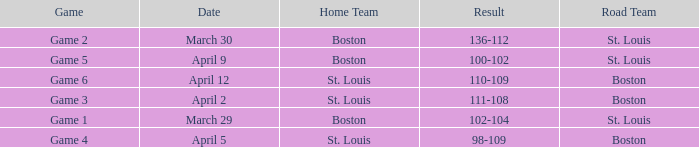What is the Result of the Game on April 9? 100-102. 